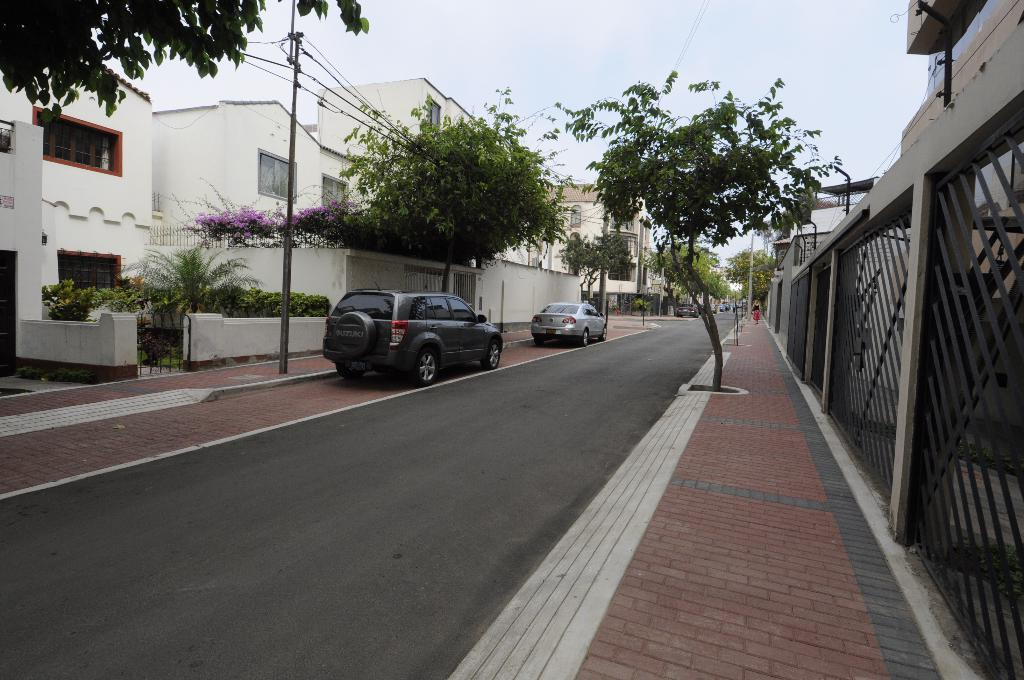What type of structures can be seen in the image? There are buildings in the image. What part of the buildings can be seen in the image? There are windows visible in the image. What architectural elements are present in the image? There are gates in the image. What type of vegetation is present in the image? There are trees and flowers in the image. What type of transportation can be seen in the image? There are vehicles on the road in the image. What part of the natural environment is visible in the image? The sky is visible in the image. Can you tell me how the stranger is connected to the buildings in the image? There is no stranger present in the image, so it is not possible to determine any connection. 